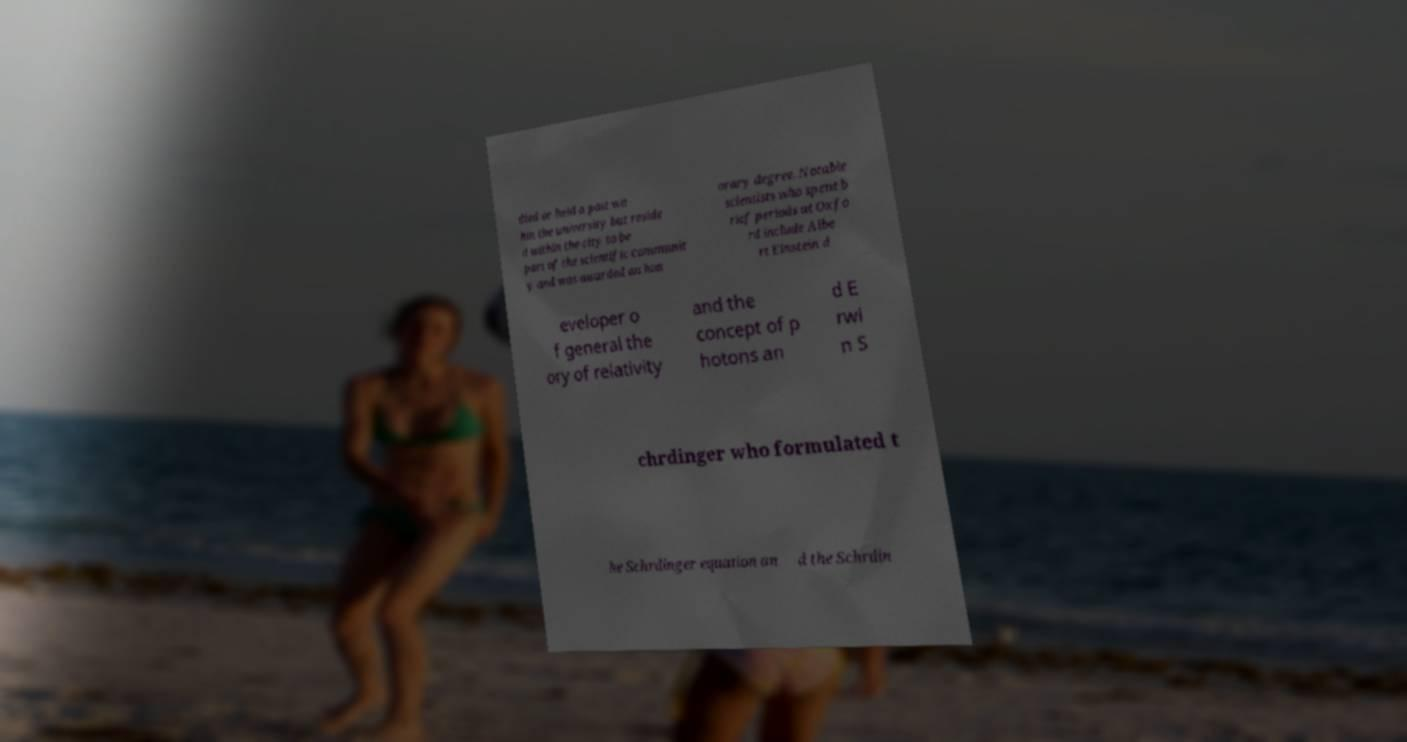For documentation purposes, I need the text within this image transcribed. Could you provide that? died or held a post wit hin the university but reside d within the city to be part of the scientific communit y and was awarded an hon orary degree. Notable scientists who spent b rief periods at Oxfo rd include Albe rt Einstein d eveloper o f general the ory of relativity and the concept of p hotons an d E rwi n S chrdinger who formulated t he Schrdinger equation an d the Schrdin 